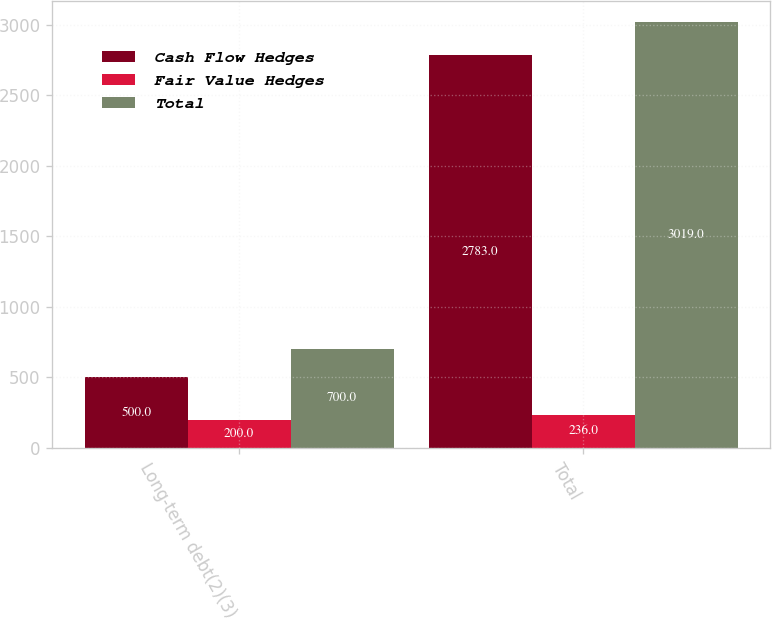<chart> <loc_0><loc_0><loc_500><loc_500><stacked_bar_chart><ecel><fcel>Long-term debt(2)(3)<fcel>Total<nl><fcel>Cash Flow Hedges<fcel>500<fcel>2783<nl><fcel>Fair Value Hedges<fcel>200<fcel>236<nl><fcel>Total<fcel>700<fcel>3019<nl></chart> 